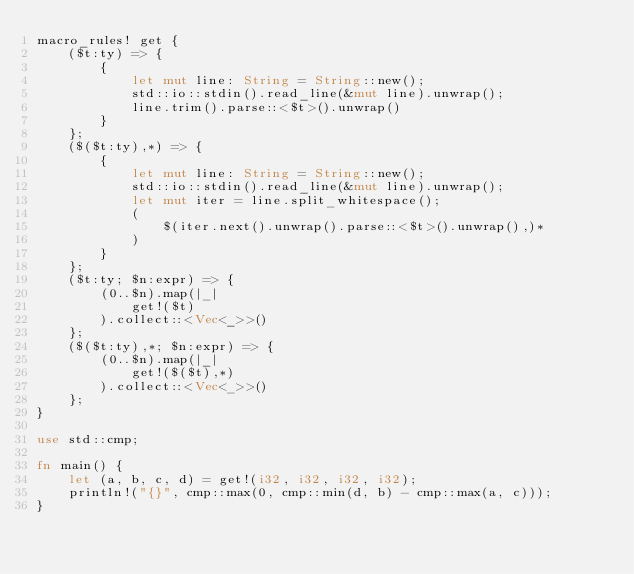<code> <loc_0><loc_0><loc_500><loc_500><_Rust_>macro_rules! get {
    ($t:ty) => {
        {
            let mut line: String = String::new();
            std::io::stdin().read_line(&mut line).unwrap();
            line.trim().parse::<$t>().unwrap()
        }
    };
    ($($t:ty),*) => {
        {
            let mut line: String = String::new();
            std::io::stdin().read_line(&mut line).unwrap();
            let mut iter = line.split_whitespace();
            (
                $(iter.next().unwrap().parse::<$t>().unwrap(),)*
            )
        }
    };
    ($t:ty; $n:expr) => {
        (0..$n).map(|_|
            get!($t)
        ).collect::<Vec<_>>()
    };
    ($($t:ty),*; $n:expr) => {
        (0..$n).map(|_|
            get!($($t),*)
        ).collect::<Vec<_>>()
    };
}

use std::cmp;

fn main() {
    let (a, b, c, d) = get!(i32, i32, i32, i32);
    println!("{}", cmp::max(0, cmp::min(d, b) - cmp::max(a, c)));
}</code> 